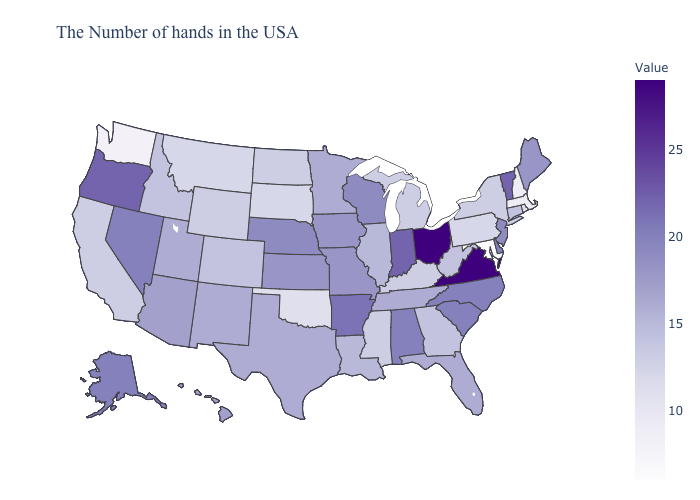Does the map have missing data?
Answer briefly. No. Among the states that border Kansas , does Colorado have the lowest value?
Short answer required. No. Is the legend a continuous bar?
Short answer required. Yes. Is the legend a continuous bar?
Be succinct. Yes. 